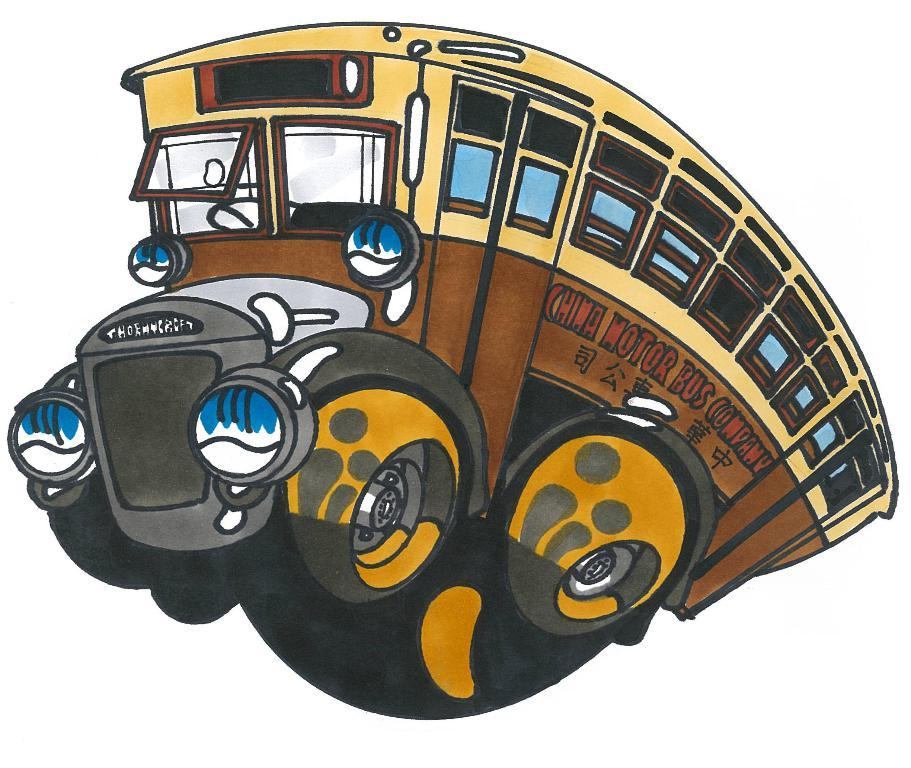What type of image is depicted in the picture? The image appears to be a drawing. What is the subject of the drawing? The drawing is of a bus. What features can be seen on the bus in the drawing? The bus has doors, windows, a steering wheel, headlights, and wheels. What type of berry is being used as a reward for the bus in the image? There is no berry or reward present in the image; it is a drawing of a bus with specific features. 